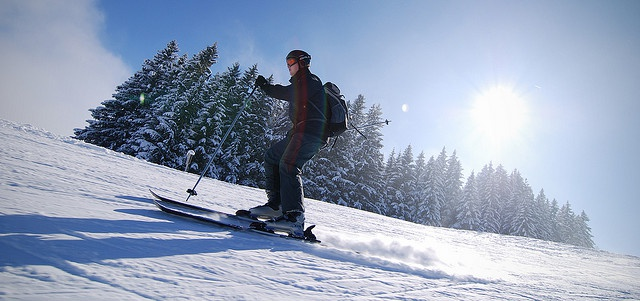Describe the objects in this image and their specific colors. I can see people in gray, black, navy, and darkblue tones, skis in gray, black, navy, and darkblue tones, and backpack in gray, black, and darkblue tones in this image. 